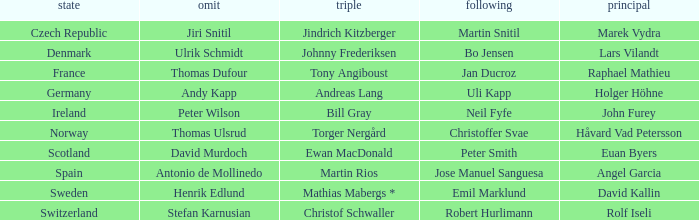Which Lead has a Nation of switzerland? Rolf Iseli. 